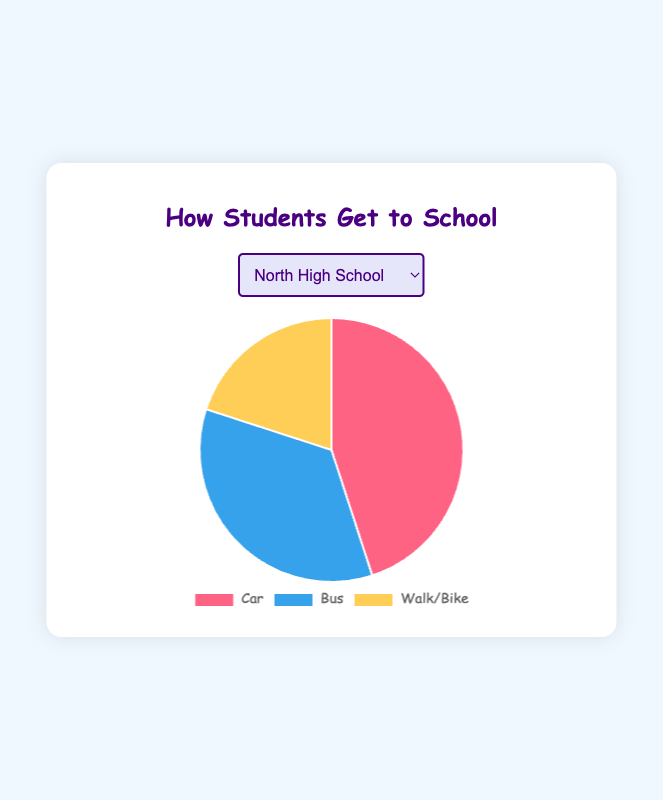Which mode of transportation is used the most by students at North High School? The pie chart indicates that 45% of students at North High School use cars, 35% use buses, and 20% walk/bike. The largest percentage is for cars.
Answer: Car Which school has the highest percentage of students who walk/bike to school? All three schools have the same percentage of 20% for students who walk/bike, as shown in their respective pie segments.
Answer: All have 20% Compare the percentage of students who use the bus at Central High School and West High School. Which school has more? Central High School has 50% of students using buses, while West High School has 40%. Comparing these values, 50% is greater than 40%.
Answer: Central High School How much higher is the percentage of students who use cars at North High School compared to Central High School? At North High School, 45% of students use cars, and at Central High School, 30% use cars. The difference is calculated as 45% - 30%.
Answer: 15% If you add up all the percentages for the modes of transportation at West High School, what is the total? Adding the percentages for car (40%), bus (40%), and walk/bike (20%) gives 40% + 40% + 20%.
Answer: 100% Among the three schools, which one has the lowest percentage of students using the car to get to school? The pie charts show 45% for North High School, 30% for Central High School, and 40% for West High School. The lowest percentage is 30% at Central High School.
Answer: Central High School What is the average percentage of students who use the bus across the three schools? The percentages of students using buses are 35% for North High School, 50% for Central High School, and 40% for West High School. Using the formula: (35 + 50 + 40) / 3.
Answer: 41.67% Which mode of transportation has an equal percentage at Central High School and West High School? At both Central and West High Schools, the percentage for walk/bike is 20%.
Answer: Walk/Bike What is the difference in the percentage of students who walk/bike between North High School and West High School? Both North High School and West High School have 20% of students walking or biking, so the difference is 20% - 20%.
Answer: 0% 